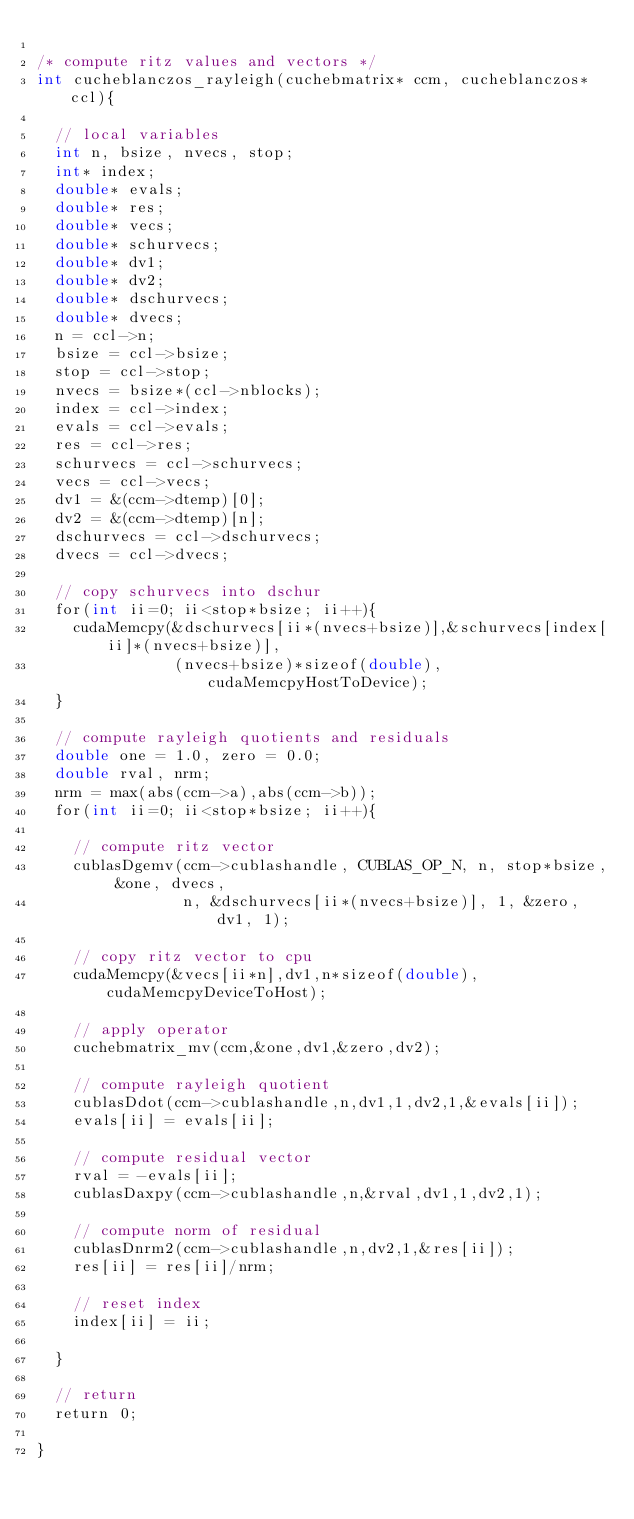<code> <loc_0><loc_0><loc_500><loc_500><_Cuda_>
/* compute ritz values and vectors */
int cucheblanczos_rayleigh(cuchebmatrix* ccm, cucheblanczos* ccl){

  // local variables
  int n, bsize, nvecs, stop;
  int* index;
  double* evals;
  double* res;
  double* vecs;
  double* schurvecs;
  double* dv1;
  double* dv2;
  double* dschurvecs;
  double* dvecs;
  n = ccl->n;
  bsize = ccl->bsize;
  stop = ccl->stop;
  nvecs = bsize*(ccl->nblocks);
  index = ccl->index;
  evals = ccl->evals;
  res = ccl->res;
  schurvecs = ccl->schurvecs;
  vecs = ccl->vecs;
  dv1 = &(ccm->dtemp)[0];
  dv2 = &(ccm->dtemp)[n];
  dschurvecs = ccl->dschurvecs;
  dvecs = ccl->dvecs;

  // copy schurvecs into dschur
  for(int ii=0; ii<stop*bsize; ii++){
    cudaMemcpy(&dschurvecs[ii*(nvecs+bsize)],&schurvecs[index[ii]*(nvecs+bsize)],
               (nvecs+bsize)*sizeof(double),cudaMemcpyHostToDevice);
  }

  // compute rayleigh quotients and residuals
  double one = 1.0, zero = 0.0;
  double rval, nrm;
  nrm = max(abs(ccm->a),abs(ccm->b));
  for(int ii=0; ii<stop*bsize; ii++){
 
    // compute ritz vector
    cublasDgemv(ccm->cublashandle, CUBLAS_OP_N, n, stop*bsize, &one, dvecs, 
                n, &dschurvecs[ii*(nvecs+bsize)], 1, &zero, dv1, 1);

    // copy ritz vector to cpu
    cudaMemcpy(&vecs[ii*n],dv1,n*sizeof(double),cudaMemcpyDeviceToHost);

    // apply operator
    cuchebmatrix_mv(ccm,&one,dv1,&zero,dv2);

    // compute rayleigh quotient
    cublasDdot(ccm->cublashandle,n,dv1,1,dv2,1,&evals[ii]);
    evals[ii] = evals[ii];

    // compute residual vector
    rval = -evals[ii];
    cublasDaxpy(ccm->cublashandle,n,&rval,dv1,1,dv2,1);

    // compute norm of residual
    cublasDnrm2(ccm->cublashandle,n,dv2,1,&res[ii]);
    res[ii] = res[ii]/nrm;

    // reset index 
    index[ii] = ii;
  
  }

  // return  
  return 0;

}
</code> 